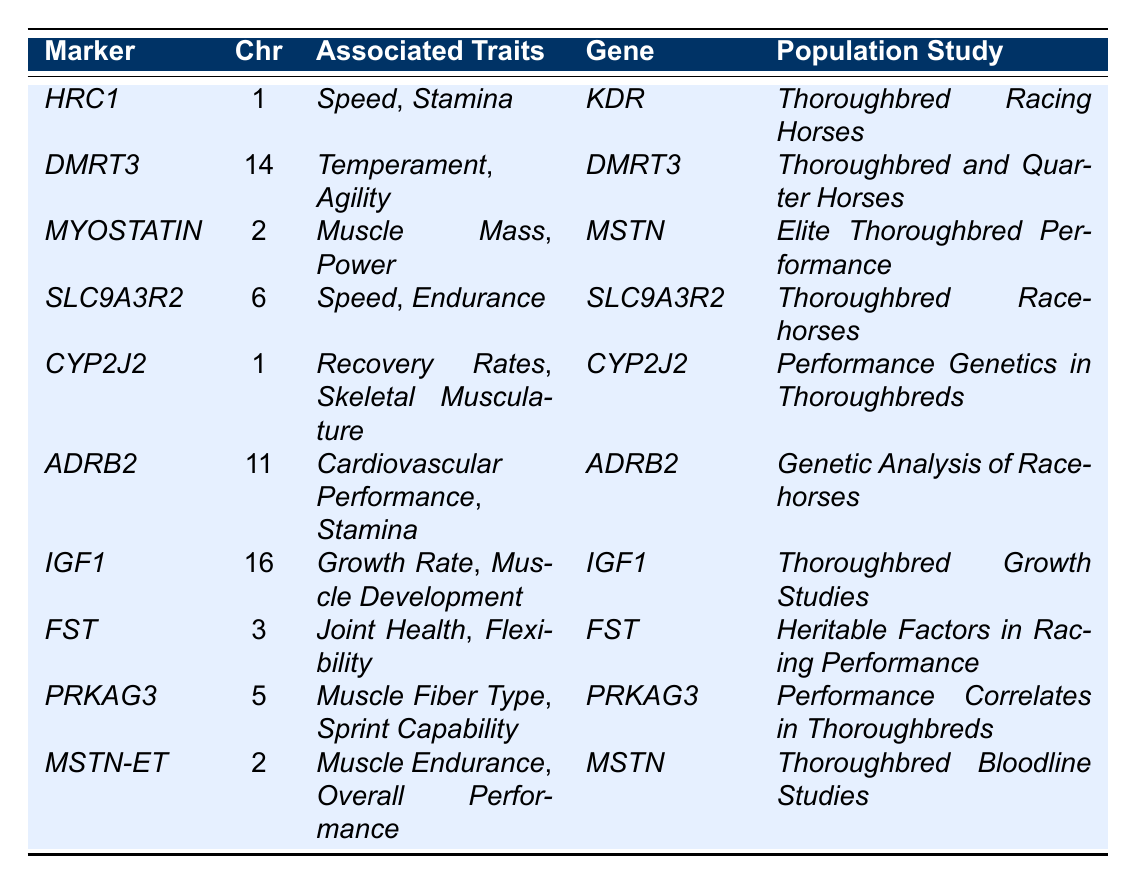What genetic marker is associated with both speed and stamina? Referring to the table, the marker _HRC1_ is listed with associated traits of _Speed_ and _Stamina_.
Answer: _HRC1_ Which chromosome is the _ADRB2_ marker located on? According to the table, the _ADRB2_ marker is found on chromosome 11.
Answer: 11 Is the _MYOSTATIN_ marker linked to muscle power? The table states that the _MYOSTATIN_ marker is associated with _Muscle Mass_ and _Power_, thus confirming the link.
Answer: Yes How many genetic markers are associated with traits related to muscle? The table shows three markers (_MYOSTATIN_, _MSTN-ET_, and _PRKAG3_) that are associated with various muscle traits (_Muscle Mass_, _Power_, _Muscle Endurance_, and _Muscle Fiber Type_).
Answer: 3 Which population studies include the marker _CYP2J2_? The table lists _CYP2J2_ under the population study titled _Performance Genetics in Thoroughbreds_.
Answer: Performance Genetics in Thoroughbreds What is the most prevalent associated trait across the markers in the table? By examining the traits listed, _Speed_ appears in two markers (_HRC1_ and _SLC9A3R2_), while others have singular associations, suggesting _Speed_ is the most prevalent.
Answer: Speed Are there any markers associated with recovery rates? The table indicates that _CYP2J2_ is associated with _Recovery Rates_, confirming that there is indeed a marker for this trait.
Answer: Yes What chromosome is associated with the _SLC9A3R2_ marker? The table specifies that the _SLC9A3R2_ marker is situated on chromosome 6.
Answer: 6 Which marker has the most diverse associated traits? Assessing the table, both _HRC1_ and _MYOSTATIN_ have two associated traits each, while others tend to indicate even fewer; thus, they hold the most diverse connection in this respect.
Answer: _HRC1_ and _MYOSTATIN_ If you were interested in a marker that influences joint health, which would you refer to? The table clearly indicates that _FST_ is associated with both _Joint Health_ and _Flexibility_.
Answer: _FST_ 